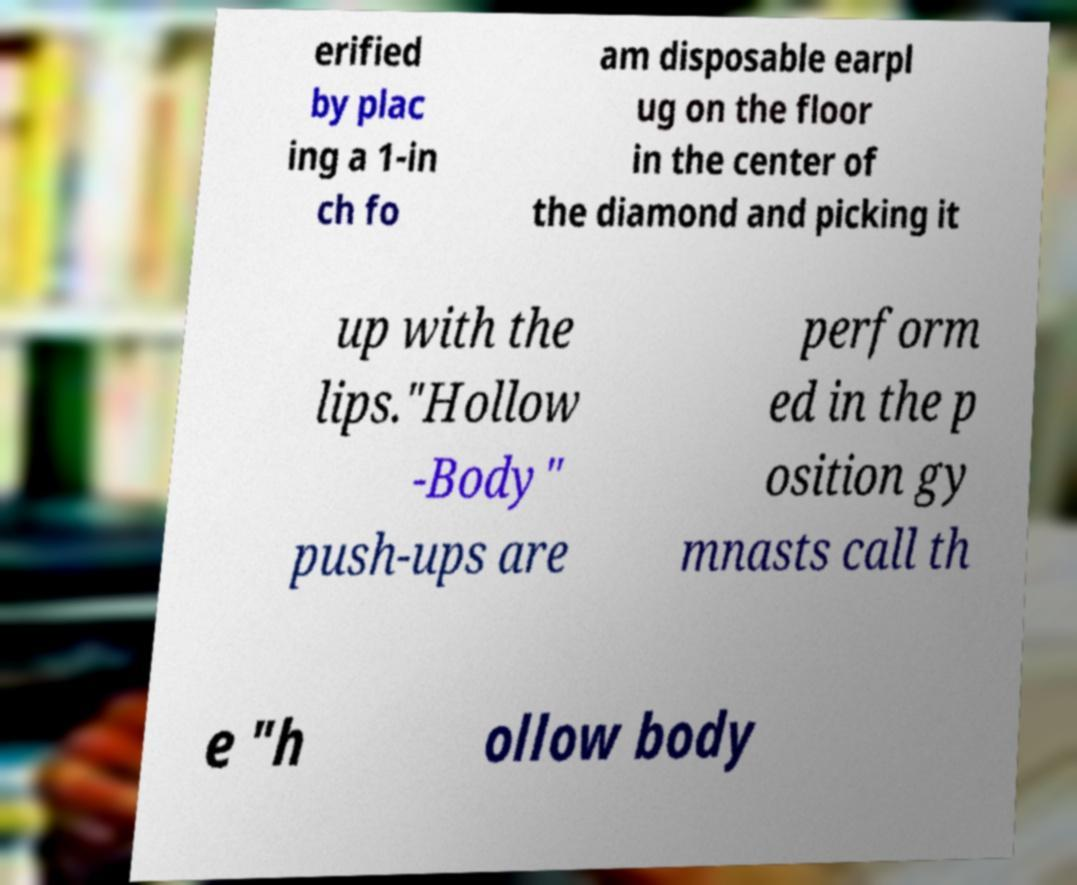Please identify and transcribe the text found in this image. erified by plac ing a 1-in ch fo am disposable earpl ug on the floor in the center of the diamond and picking it up with the lips."Hollow -Body" push-ups are perform ed in the p osition gy mnasts call th e "h ollow body 